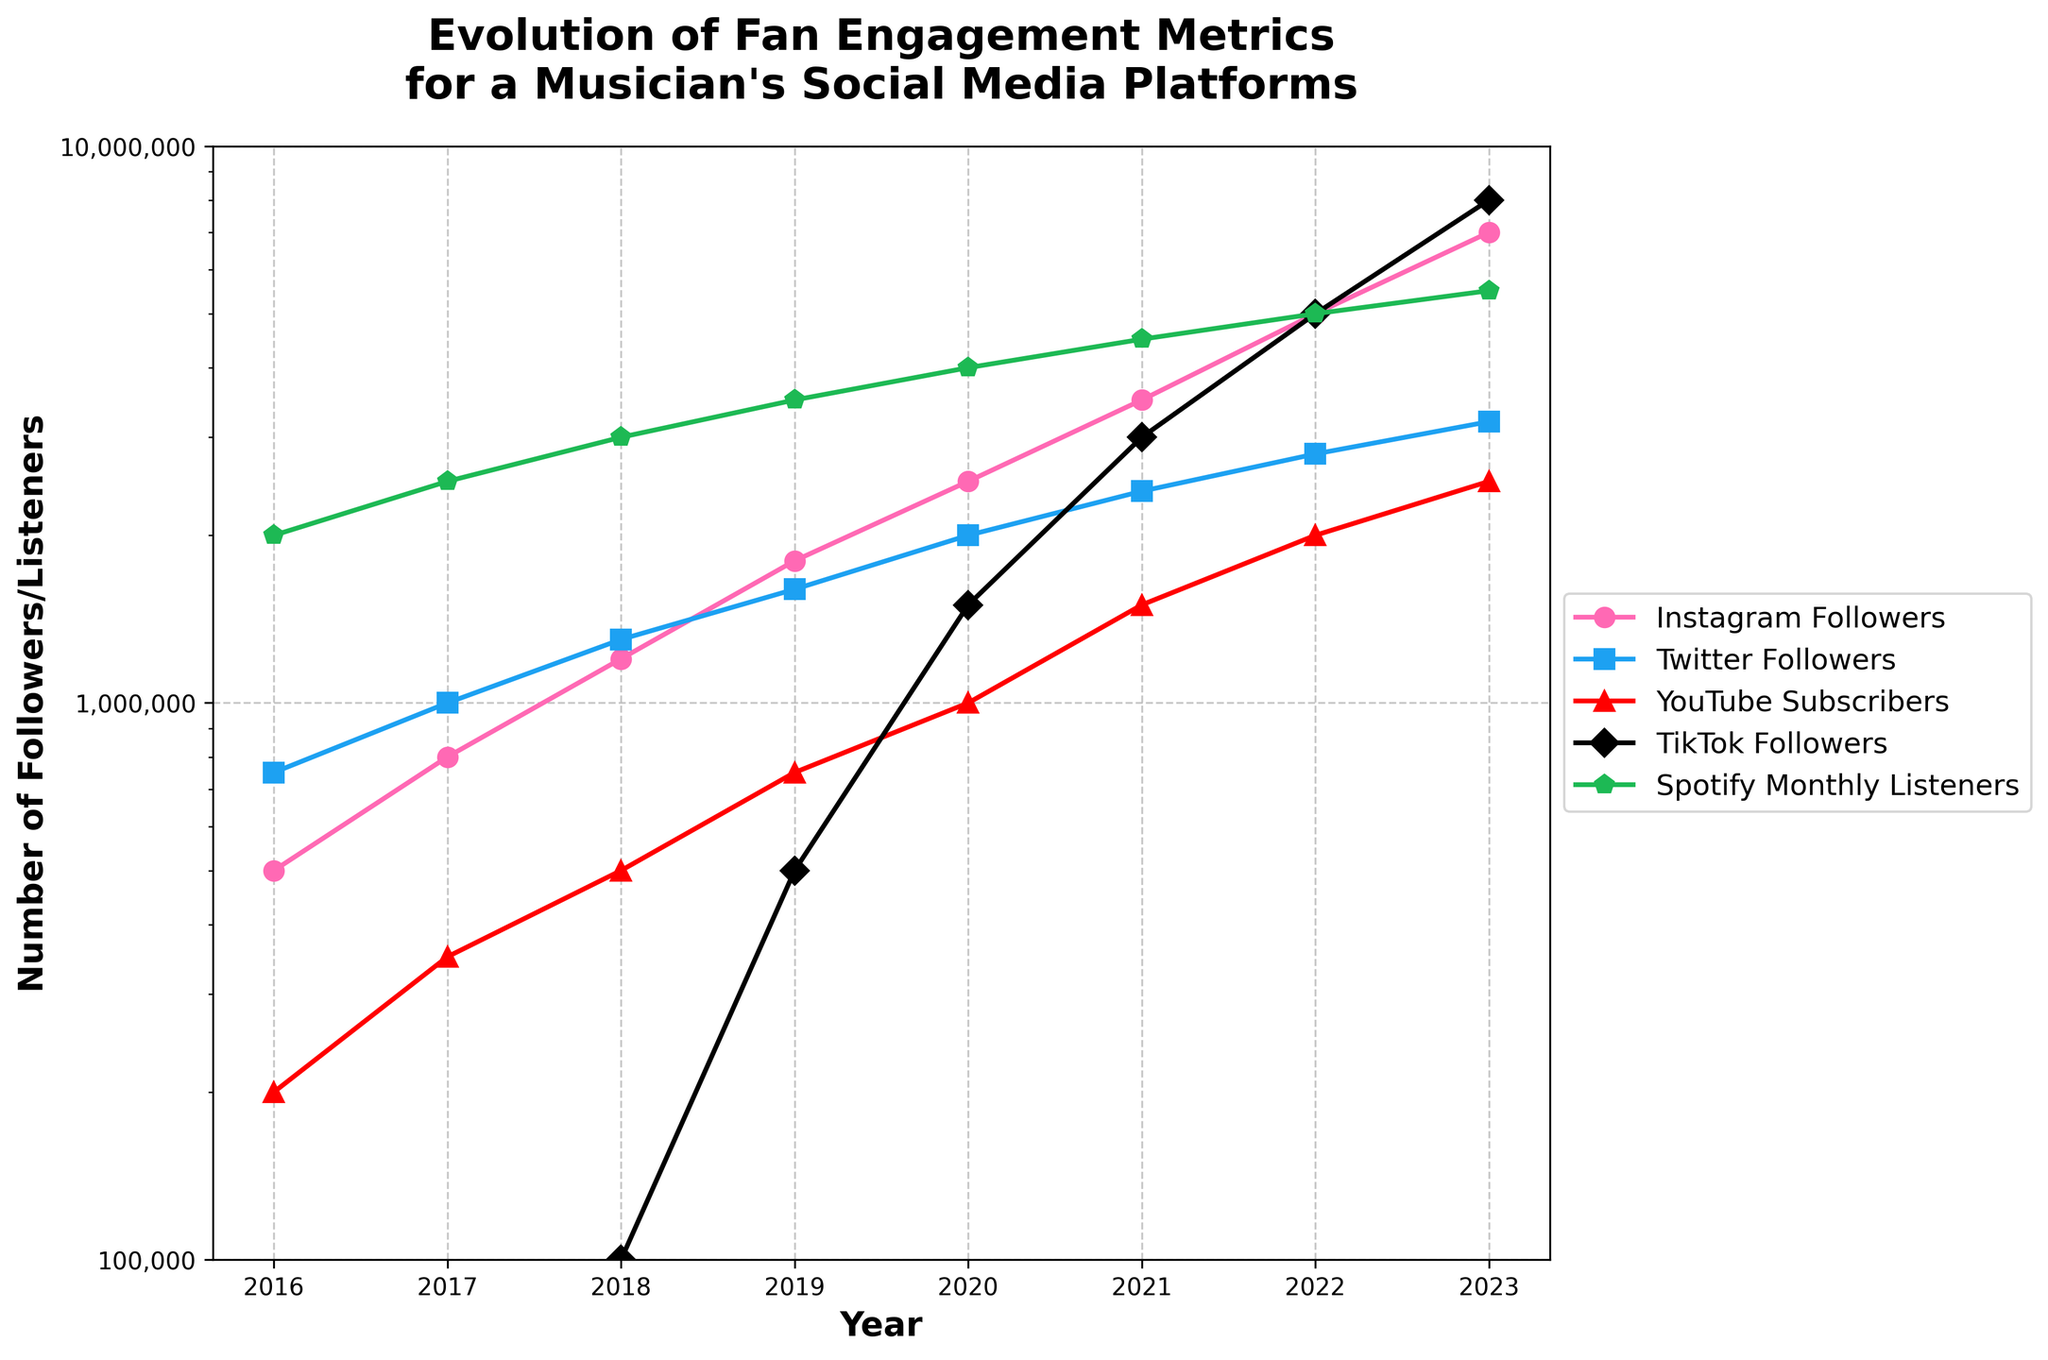What was the trend in TikTok Followers from 2019 to 2023? From the chart, notice the increase in the number of TikTok Followers each year from 2019 (500,000) to 2023 (8,000,000). This consistent growth shows a sharp upward trend.
Answer: Sharp upward trend Which year saw the highest increase in Instagram Followers compared to the previous year? By comparing yearly increments, 2023 had the highest increase in Instagram Followers jumping from 5,000,000 in 2022 to 7,000,000 in 2023, an increase of 2,000,000.
Answer: 2023 How do the growth trends of Spotify Monthly Listeners and YouTube Subscribers compare between 2016 and 2023? From the chart, Spotify Monthly Listeners show a steadier and more pronounced growth from 2,000,000 in 2016 to 5,500,000 in 2023. Meanwhile, YouTube Subscribers also increased steadily but started slower and reached 2,500,000 by 2023.
Answer: Spotify had more rapid growth Estimate the average number of Instagram Followers from 2019 to 2023. Summing the Instagram Followers from 2019 (1,800,000), 2020 (2,500,000), 2021 (3,500,000), 2022 (5,000,000), and 2023 (7,000,000) gives 19,800,000. Dividing this by 5, the average is 3,960,000.
Answer: 3,960,000 Which platform had the lowest number of followers in 2023? By observing the endpoints on the chart for 2023, Twitter had the lowest number of followers at 3,200,000.
Answer: Twitter What was the total number of followers/listeners across all platforms in 2020? Summing the 2020 values: Instagram (2,500,000), Twitter (2,000,000), YouTube (1,000,000), TikTok (1,500,000), and Spotify (4,000,000) results in a total of 11,000,000.
Answer: 11,000,000 What is the difference in growth rate between Instagram Followers and TikTok Followers from 2021 to 2022? Instagram grew from 3,500,000 in 2021 to 5,000,000 in 2022, an increase of 1,500,000. TikTok grew from 3,000,000 to 5,000,000, an increase of 2,000,000. The difference in their growth rates is 500,000.
Answer: 500,000 How did the number of YouTube Subscribers change from 2016 to 2023? From the chart, YouTube Subscribers grew from 200,000 in 2016 to 2,500,000 in 2023. This indicates a substantial increase over the period.
Answer: Substantial increase What is common among all the platforms' trends from 2016 to 2023? All platforms show an upward trend from 2016 to 2023, indicating continuous follower/listener growth over the years.
Answer: Upward trend How did the number of Twitter Followers in 2022 compare to the number of TikTok Followers in 2022? The chart shows Twitter Followers at 2,800,000 in 2022, while TikTok Followers were higher at 5,000,000 in the same year.
Answer: TikTok was higher 